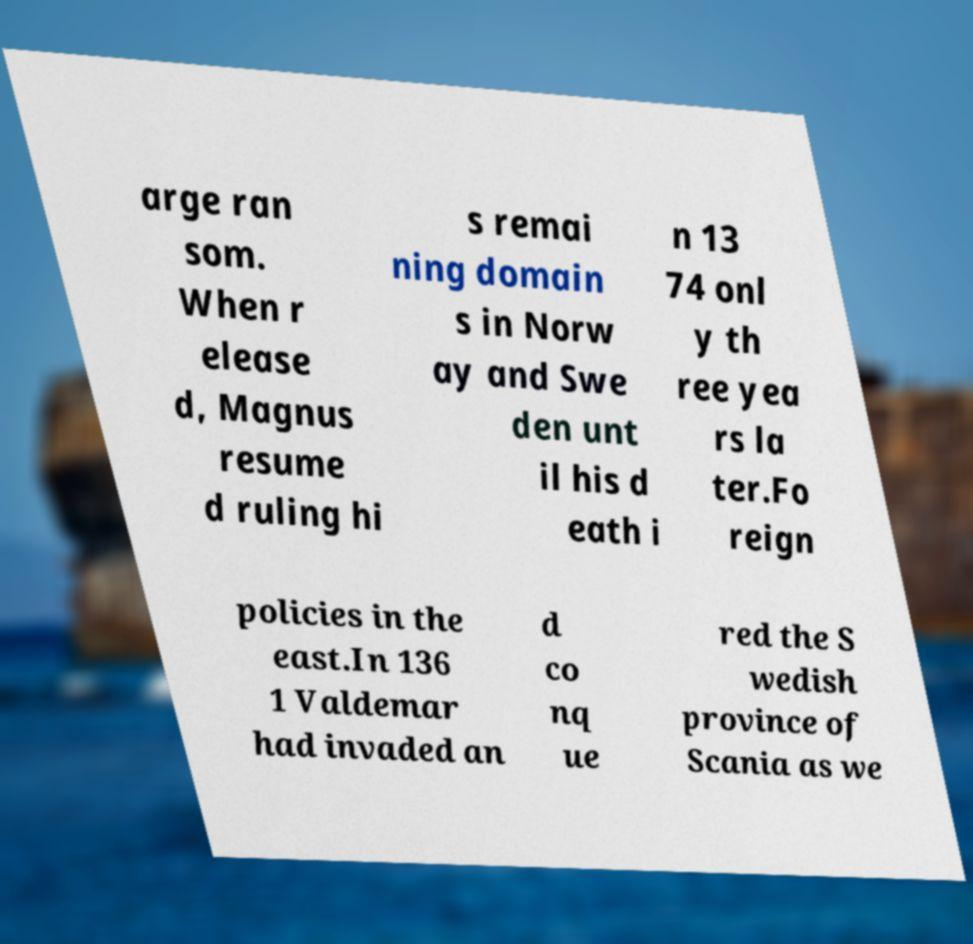There's text embedded in this image that I need extracted. Can you transcribe it verbatim? arge ran som. When r elease d, Magnus resume d ruling hi s remai ning domain s in Norw ay and Swe den unt il his d eath i n 13 74 onl y th ree yea rs la ter.Fo reign policies in the east.In 136 1 Valdemar had invaded an d co nq ue red the S wedish province of Scania as we 